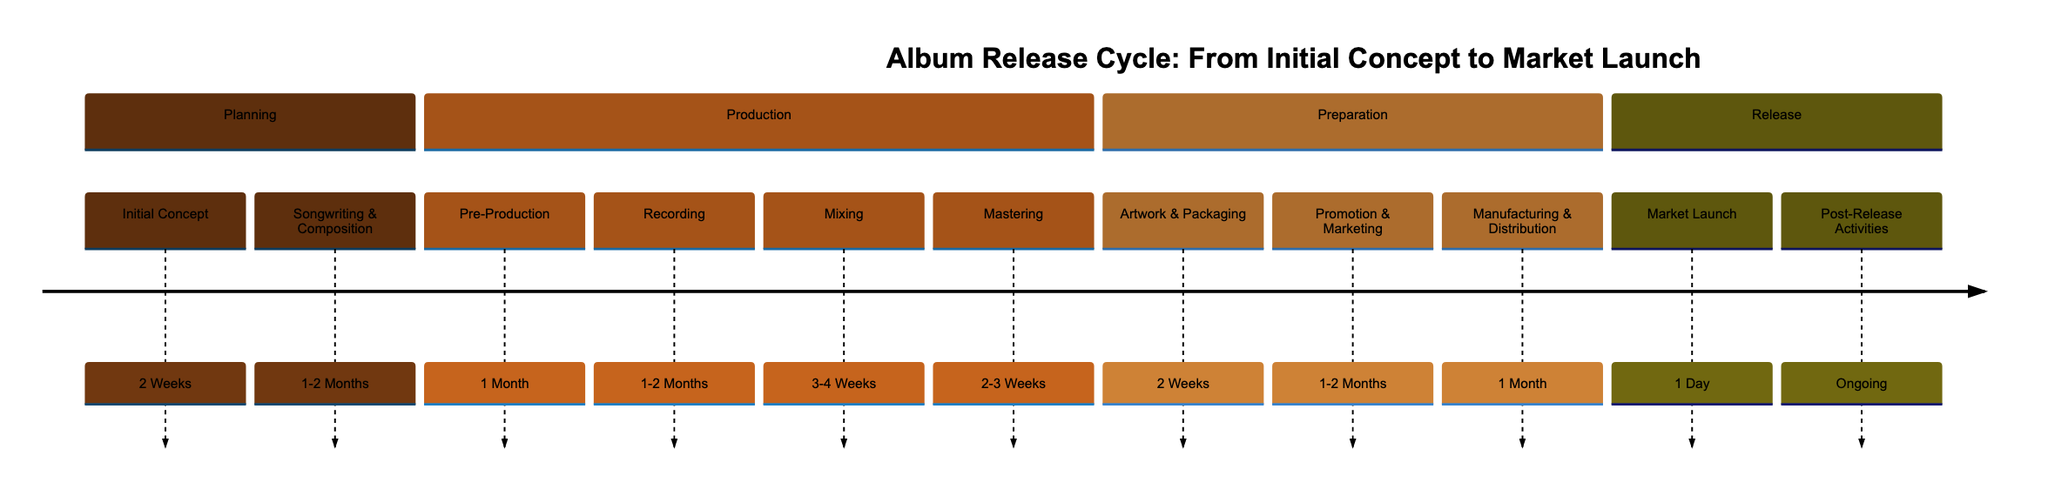What is the time frame for the Initial Concept stage? The diagram indicates that the Initial Concept stage lasts for 2 Weeks. This information can be easily found next to the corresponding stage in the timeline.
Answer: 2 Weeks How long does the Mixing stage take? The Mixing stage is shown in the diagram with a time frame of 3-4 Weeks, which can also be located next to the Mixing node on the timeline.
Answer: 3-4 Weeks What is the final stage before the Market Launch? In the timeline, the stage immediately preceding the Market Launch is Manufacturing & Distribution. This relationship can be traced directly from the flow of the diagram.
Answer: Manufacturing & Distribution Which stage occurs right after the Recording stage? According to the diagram, the Mixing stage follows the Recording stage. This is determined by analyzing the sequence of stages presented in the timeline.
Answer: Mixing How many total stages are in the Production section? There are four stages listed in the Production section: Pre-Production, Recording, Mixing, and Mastering. This can be counted by reviewing the nodes specifically in the Production category of the timeline.
Answer: 4 What is the total time frame for the Preparation section? The Preparation section consists of three stages (Artwork & Packaging, Promotion & Marketing, Manufacturing & Distribution) with respective time frames of 2 Weeks, 1-2 Months, and 1 Month. Converting these into weeks gives us an approximate range of 10-14 weeks total.
Answer: 10-14 weeks When does the Post-Release Activities begin? The diagram indicates that Post-Release Activities are ongoing, which means they start immediately after the Market Launch stage. This can be inferred from the flow connecting these stages in the timeline.
Answer: Ongoing Which stage requires the least amount of time? The Market Launch stage requires only 1 Day, as indicated in the timeline. This is the shortest time frame noted amongst all the stages presented.
Answer: 1 Day What is the main focus during the Promotion & Marketing stage? The diagram describes the Promotion & Marketing stage as focusing on planning and executing marketing strategies. This can be easily referenced in the descriptive information associated with that stage.
Answer: Planning and executing marketing strategies 